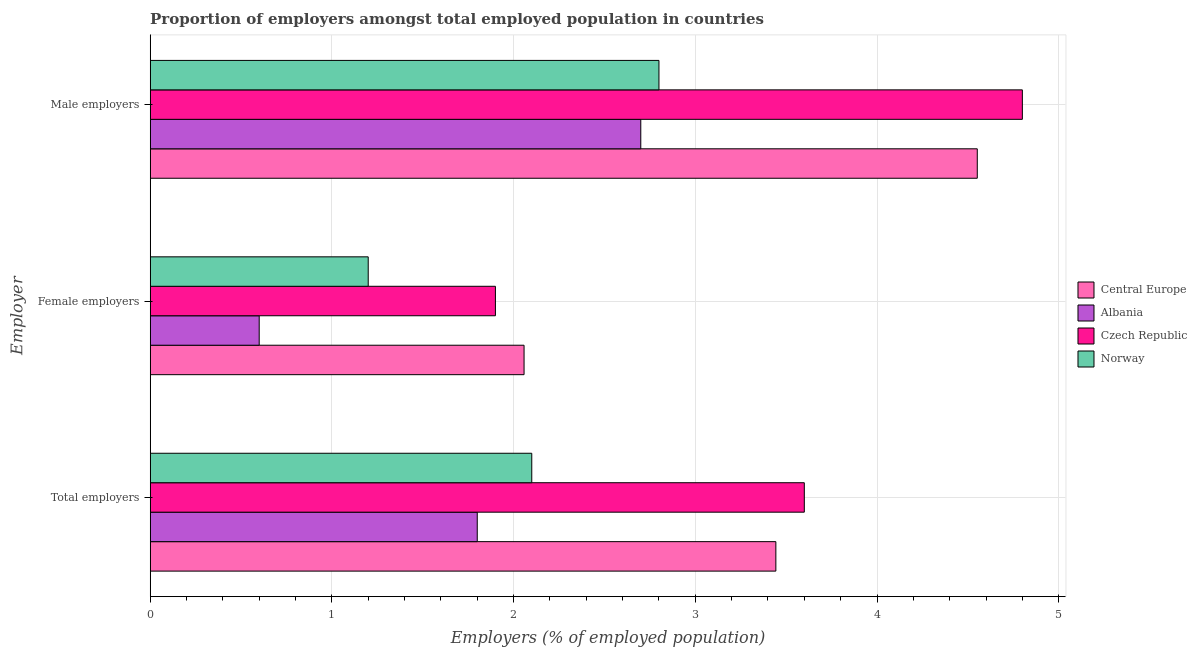How many different coloured bars are there?
Keep it short and to the point. 4. How many groups of bars are there?
Offer a very short reply. 3. How many bars are there on the 2nd tick from the top?
Give a very brief answer. 4. How many bars are there on the 3rd tick from the bottom?
Your answer should be compact. 4. What is the label of the 1st group of bars from the top?
Give a very brief answer. Male employers. What is the percentage of total employers in Albania?
Keep it short and to the point. 1.8. Across all countries, what is the maximum percentage of female employers?
Your answer should be compact. 2.06. Across all countries, what is the minimum percentage of female employers?
Offer a very short reply. 0.6. In which country was the percentage of total employers maximum?
Give a very brief answer. Czech Republic. In which country was the percentage of total employers minimum?
Your answer should be compact. Albania. What is the total percentage of female employers in the graph?
Make the answer very short. 5.76. What is the difference between the percentage of female employers in Central Europe and that in Albania?
Make the answer very short. 1.46. What is the difference between the percentage of female employers in Albania and the percentage of male employers in Central Europe?
Offer a very short reply. -3.95. What is the average percentage of female employers per country?
Ensure brevity in your answer.  1.44. What is the difference between the percentage of male employers and percentage of total employers in Czech Republic?
Make the answer very short. 1.2. In how many countries, is the percentage of male employers greater than 3 %?
Provide a succinct answer. 2. What is the ratio of the percentage of total employers in Norway to that in Central Europe?
Your response must be concise. 0.61. Is the difference between the percentage of male employers in Czech Republic and Norway greater than the difference between the percentage of female employers in Czech Republic and Norway?
Provide a short and direct response. Yes. What is the difference between the highest and the second highest percentage of female employers?
Offer a very short reply. 0.16. What is the difference between the highest and the lowest percentage of male employers?
Your response must be concise. 2.1. Is the sum of the percentage of male employers in Czech Republic and Central Europe greater than the maximum percentage of total employers across all countries?
Your answer should be compact. Yes. What does the 4th bar from the top in Female employers represents?
Make the answer very short. Central Europe. What does the 2nd bar from the bottom in Female employers represents?
Make the answer very short. Albania. Is it the case that in every country, the sum of the percentage of total employers and percentage of female employers is greater than the percentage of male employers?
Your answer should be very brief. No. Are all the bars in the graph horizontal?
Provide a short and direct response. Yes. What is the difference between two consecutive major ticks on the X-axis?
Your answer should be very brief. 1. Are the values on the major ticks of X-axis written in scientific E-notation?
Ensure brevity in your answer.  No. How many legend labels are there?
Offer a very short reply. 4. What is the title of the graph?
Offer a terse response. Proportion of employers amongst total employed population in countries. Does "Caribbean small states" appear as one of the legend labels in the graph?
Provide a short and direct response. No. What is the label or title of the X-axis?
Your answer should be very brief. Employers (% of employed population). What is the label or title of the Y-axis?
Your answer should be very brief. Employer. What is the Employers (% of employed population) in Central Europe in Total employers?
Your answer should be very brief. 3.44. What is the Employers (% of employed population) in Albania in Total employers?
Offer a terse response. 1.8. What is the Employers (% of employed population) of Czech Republic in Total employers?
Give a very brief answer. 3.6. What is the Employers (% of employed population) in Norway in Total employers?
Ensure brevity in your answer.  2.1. What is the Employers (% of employed population) of Central Europe in Female employers?
Ensure brevity in your answer.  2.06. What is the Employers (% of employed population) of Albania in Female employers?
Offer a very short reply. 0.6. What is the Employers (% of employed population) in Czech Republic in Female employers?
Ensure brevity in your answer.  1.9. What is the Employers (% of employed population) of Norway in Female employers?
Offer a terse response. 1.2. What is the Employers (% of employed population) of Central Europe in Male employers?
Provide a succinct answer. 4.55. What is the Employers (% of employed population) in Albania in Male employers?
Offer a very short reply. 2.7. What is the Employers (% of employed population) of Czech Republic in Male employers?
Provide a succinct answer. 4.8. What is the Employers (% of employed population) in Norway in Male employers?
Keep it short and to the point. 2.8. Across all Employer, what is the maximum Employers (% of employed population) in Central Europe?
Provide a succinct answer. 4.55. Across all Employer, what is the maximum Employers (% of employed population) of Albania?
Keep it short and to the point. 2.7. Across all Employer, what is the maximum Employers (% of employed population) in Czech Republic?
Offer a terse response. 4.8. Across all Employer, what is the maximum Employers (% of employed population) in Norway?
Keep it short and to the point. 2.8. Across all Employer, what is the minimum Employers (% of employed population) in Central Europe?
Your answer should be compact. 2.06. Across all Employer, what is the minimum Employers (% of employed population) of Albania?
Your answer should be compact. 0.6. Across all Employer, what is the minimum Employers (% of employed population) in Czech Republic?
Provide a short and direct response. 1.9. Across all Employer, what is the minimum Employers (% of employed population) of Norway?
Your answer should be compact. 1.2. What is the total Employers (% of employed population) in Central Europe in the graph?
Ensure brevity in your answer.  10.05. What is the total Employers (% of employed population) in Czech Republic in the graph?
Offer a very short reply. 10.3. What is the difference between the Employers (% of employed population) of Central Europe in Total employers and that in Female employers?
Provide a succinct answer. 1.39. What is the difference between the Employers (% of employed population) in Albania in Total employers and that in Female employers?
Offer a terse response. 1.2. What is the difference between the Employers (% of employed population) in Czech Republic in Total employers and that in Female employers?
Provide a succinct answer. 1.7. What is the difference between the Employers (% of employed population) of Norway in Total employers and that in Female employers?
Your answer should be very brief. 0.9. What is the difference between the Employers (% of employed population) of Central Europe in Total employers and that in Male employers?
Give a very brief answer. -1.11. What is the difference between the Employers (% of employed population) in Czech Republic in Total employers and that in Male employers?
Your response must be concise. -1.2. What is the difference between the Employers (% of employed population) of Central Europe in Female employers and that in Male employers?
Your response must be concise. -2.49. What is the difference between the Employers (% of employed population) of Norway in Female employers and that in Male employers?
Give a very brief answer. -1.6. What is the difference between the Employers (% of employed population) of Central Europe in Total employers and the Employers (% of employed population) of Albania in Female employers?
Provide a succinct answer. 2.84. What is the difference between the Employers (% of employed population) of Central Europe in Total employers and the Employers (% of employed population) of Czech Republic in Female employers?
Your answer should be compact. 1.54. What is the difference between the Employers (% of employed population) of Central Europe in Total employers and the Employers (% of employed population) of Norway in Female employers?
Keep it short and to the point. 2.24. What is the difference between the Employers (% of employed population) in Albania in Total employers and the Employers (% of employed population) in Norway in Female employers?
Provide a short and direct response. 0.6. What is the difference between the Employers (% of employed population) in Central Europe in Total employers and the Employers (% of employed population) in Albania in Male employers?
Your answer should be compact. 0.74. What is the difference between the Employers (% of employed population) of Central Europe in Total employers and the Employers (% of employed population) of Czech Republic in Male employers?
Offer a very short reply. -1.36. What is the difference between the Employers (% of employed population) in Central Europe in Total employers and the Employers (% of employed population) in Norway in Male employers?
Provide a short and direct response. 0.64. What is the difference between the Employers (% of employed population) in Albania in Total employers and the Employers (% of employed population) in Czech Republic in Male employers?
Provide a succinct answer. -3. What is the difference between the Employers (% of employed population) of Czech Republic in Total employers and the Employers (% of employed population) of Norway in Male employers?
Offer a very short reply. 0.8. What is the difference between the Employers (% of employed population) in Central Europe in Female employers and the Employers (% of employed population) in Albania in Male employers?
Offer a very short reply. -0.64. What is the difference between the Employers (% of employed population) in Central Europe in Female employers and the Employers (% of employed population) in Czech Republic in Male employers?
Your answer should be very brief. -2.74. What is the difference between the Employers (% of employed population) of Central Europe in Female employers and the Employers (% of employed population) of Norway in Male employers?
Your response must be concise. -0.74. What is the difference between the Employers (% of employed population) of Czech Republic in Female employers and the Employers (% of employed population) of Norway in Male employers?
Give a very brief answer. -0.9. What is the average Employers (% of employed population) in Central Europe per Employer?
Your answer should be compact. 3.35. What is the average Employers (% of employed population) in Albania per Employer?
Give a very brief answer. 1.7. What is the average Employers (% of employed population) in Czech Republic per Employer?
Ensure brevity in your answer.  3.43. What is the average Employers (% of employed population) in Norway per Employer?
Ensure brevity in your answer.  2.03. What is the difference between the Employers (% of employed population) of Central Europe and Employers (% of employed population) of Albania in Total employers?
Your response must be concise. 1.64. What is the difference between the Employers (% of employed population) of Central Europe and Employers (% of employed population) of Czech Republic in Total employers?
Your response must be concise. -0.16. What is the difference between the Employers (% of employed population) of Central Europe and Employers (% of employed population) of Norway in Total employers?
Offer a very short reply. 1.34. What is the difference between the Employers (% of employed population) in Czech Republic and Employers (% of employed population) in Norway in Total employers?
Offer a terse response. 1.5. What is the difference between the Employers (% of employed population) in Central Europe and Employers (% of employed population) in Albania in Female employers?
Ensure brevity in your answer.  1.46. What is the difference between the Employers (% of employed population) of Central Europe and Employers (% of employed population) of Czech Republic in Female employers?
Provide a succinct answer. 0.16. What is the difference between the Employers (% of employed population) of Central Europe and Employers (% of employed population) of Norway in Female employers?
Keep it short and to the point. 0.86. What is the difference between the Employers (% of employed population) in Albania and Employers (% of employed population) in Czech Republic in Female employers?
Give a very brief answer. -1.3. What is the difference between the Employers (% of employed population) in Central Europe and Employers (% of employed population) in Albania in Male employers?
Provide a succinct answer. 1.85. What is the difference between the Employers (% of employed population) of Central Europe and Employers (% of employed population) of Czech Republic in Male employers?
Provide a succinct answer. -0.25. What is the difference between the Employers (% of employed population) in Central Europe and Employers (% of employed population) in Norway in Male employers?
Your answer should be very brief. 1.75. What is the difference between the Employers (% of employed population) of Albania and Employers (% of employed population) of Czech Republic in Male employers?
Ensure brevity in your answer.  -2.1. What is the difference between the Employers (% of employed population) in Albania and Employers (% of employed population) in Norway in Male employers?
Offer a very short reply. -0.1. What is the ratio of the Employers (% of employed population) of Central Europe in Total employers to that in Female employers?
Your answer should be compact. 1.67. What is the ratio of the Employers (% of employed population) in Czech Republic in Total employers to that in Female employers?
Your answer should be very brief. 1.89. What is the ratio of the Employers (% of employed population) in Central Europe in Total employers to that in Male employers?
Provide a short and direct response. 0.76. What is the ratio of the Employers (% of employed population) in Central Europe in Female employers to that in Male employers?
Make the answer very short. 0.45. What is the ratio of the Employers (% of employed population) of Albania in Female employers to that in Male employers?
Ensure brevity in your answer.  0.22. What is the ratio of the Employers (% of employed population) in Czech Republic in Female employers to that in Male employers?
Your answer should be compact. 0.4. What is the ratio of the Employers (% of employed population) in Norway in Female employers to that in Male employers?
Your answer should be compact. 0.43. What is the difference between the highest and the second highest Employers (% of employed population) of Central Europe?
Provide a short and direct response. 1.11. What is the difference between the highest and the second highest Employers (% of employed population) in Albania?
Keep it short and to the point. 0.9. What is the difference between the highest and the second highest Employers (% of employed population) in Czech Republic?
Provide a succinct answer. 1.2. What is the difference between the highest and the second highest Employers (% of employed population) of Norway?
Ensure brevity in your answer.  0.7. What is the difference between the highest and the lowest Employers (% of employed population) in Central Europe?
Offer a terse response. 2.49. What is the difference between the highest and the lowest Employers (% of employed population) of Albania?
Your response must be concise. 2.1. What is the difference between the highest and the lowest Employers (% of employed population) of Czech Republic?
Offer a very short reply. 2.9. What is the difference between the highest and the lowest Employers (% of employed population) in Norway?
Your answer should be compact. 1.6. 